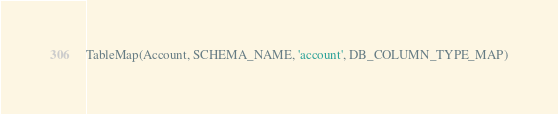<code> <loc_0><loc_0><loc_500><loc_500><_Python_>
TableMap(Account, SCHEMA_NAME, 'account', DB_COLUMN_TYPE_MAP)

</code> 